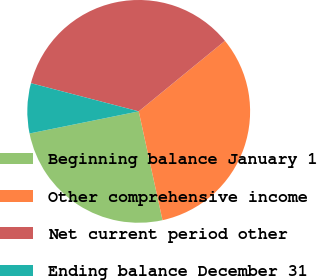Convert chart to OTSL. <chart><loc_0><loc_0><loc_500><loc_500><pie_chart><fcel>Beginning balance January 1<fcel>Other comprehensive income<fcel>Net current period other<fcel>Ending balance December 31<nl><fcel>25.25%<fcel>32.49%<fcel>35.02%<fcel>7.25%<nl></chart> 